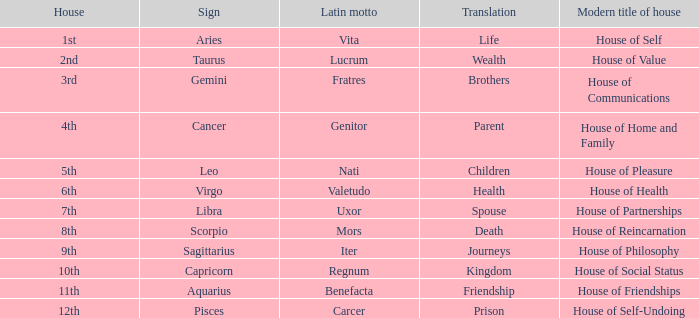What is the current designation for the first house? House of Self. Can you parse all the data within this table? {'header': ['House', 'Sign', 'Latin motto', 'Translation', 'Modern title of house'], 'rows': [['1st', 'Aries', 'Vita', 'Life', 'House of Self'], ['2nd', 'Taurus', 'Lucrum', 'Wealth', 'House of Value'], ['3rd', 'Gemini', 'Fratres', 'Brothers', 'House of Communications'], ['4th', 'Cancer', 'Genitor', 'Parent', 'House of Home and Family'], ['5th', 'Leo', 'Nati', 'Children', 'House of Pleasure'], ['6th', 'Virgo', 'Valetudo', 'Health', 'House of Health'], ['7th', 'Libra', 'Uxor', 'Spouse', 'House of Partnerships'], ['8th', 'Scorpio', 'Mors', 'Death', 'House of Reincarnation'], ['9th', 'Sagittarius', 'Iter', 'Journeys', 'House of Philosophy'], ['10th', 'Capricorn', 'Regnum', 'Kingdom', 'House of Social Status'], ['11th', 'Aquarius', 'Benefacta', 'Friendship', 'House of Friendships'], ['12th', 'Pisces', 'Carcer', 'Prison', 'House of Self-Undoing']]} 